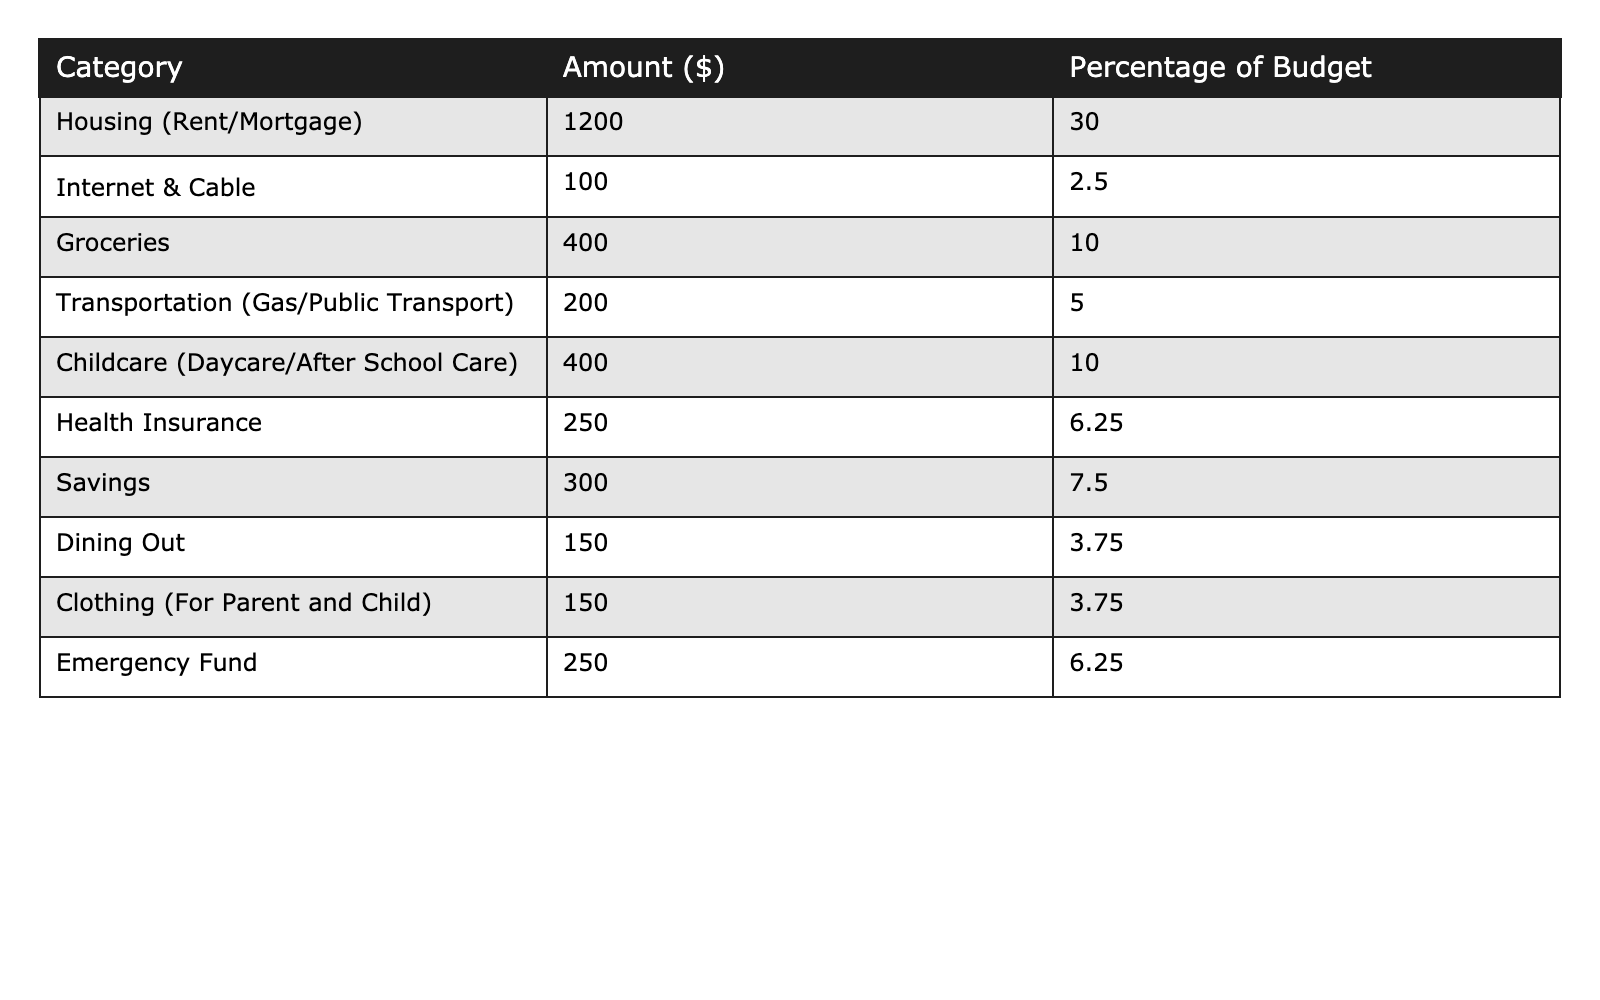What is the total amount spent on housing? The table shows that the housing category (Rent/Mortgage) has an amount of $1200. This is the total amount spent on housing.
Answer: $1200 What percentage of the budget is allocated to groceries? The table indicates that groceries account for 10% of the budget.
Answer: 10% Is the amount spent on childcare equal to the amount saved? The amount for childcare (Daycare/After School Care) is $400, while the savings amount is $300. Since $400 is not equal to $300, the answer is no.
Answer: No What is the combined total spent on health insurance and dining out? The table shows health insurance is $250 and dining out is $150. Adding these amounts: $250 + $150 = $400.
Answer: $400 Which category has the highest percentage of the budget? The highest percentage in the table is 30% for Housing (Rent/Mortgage).
Answer: Housing (Rent/Mortgage) What is the total budget amount represented in the table? To find the total budget, sum up all the amounts. So, $1200 + $100 + $400 + $200 + $400 + $250 + $300 + $150 + $150 + $250 = $3200.
Answer: $3200 If I wanted to decrease my dining out budget by 50%, how much would that leave? Current spending on dining out is $150. If reduced by 50%, the calculation is $150 - ($150 * 0.5) = $150 - $75 = $75 remaining.
Answer: $75 What is the difference in amount between the highest and lowest spending categories? The highest spending category is Housing at $1200, and the lowest is Internet & Cable at $100. The difference is $1200 - $100 = $1100.
Answer: $1100 What fraction of the total budget is represented by the emergency fund? The amount for the emergency fund is $250, and the total budget is $3200. The fraction is calculated as $250 / $3200 = 0.078125, which simplifies to approximately 1/13 when expressed as a fraction.
Answer: 1/13 Is the total amount spent on transportation greater than the combined amount spent on internet and cable? Transportation costs $200, while internet and cable combined is $100. Since $200 is greater than $100, the answer is yes.
Answer: Yes 